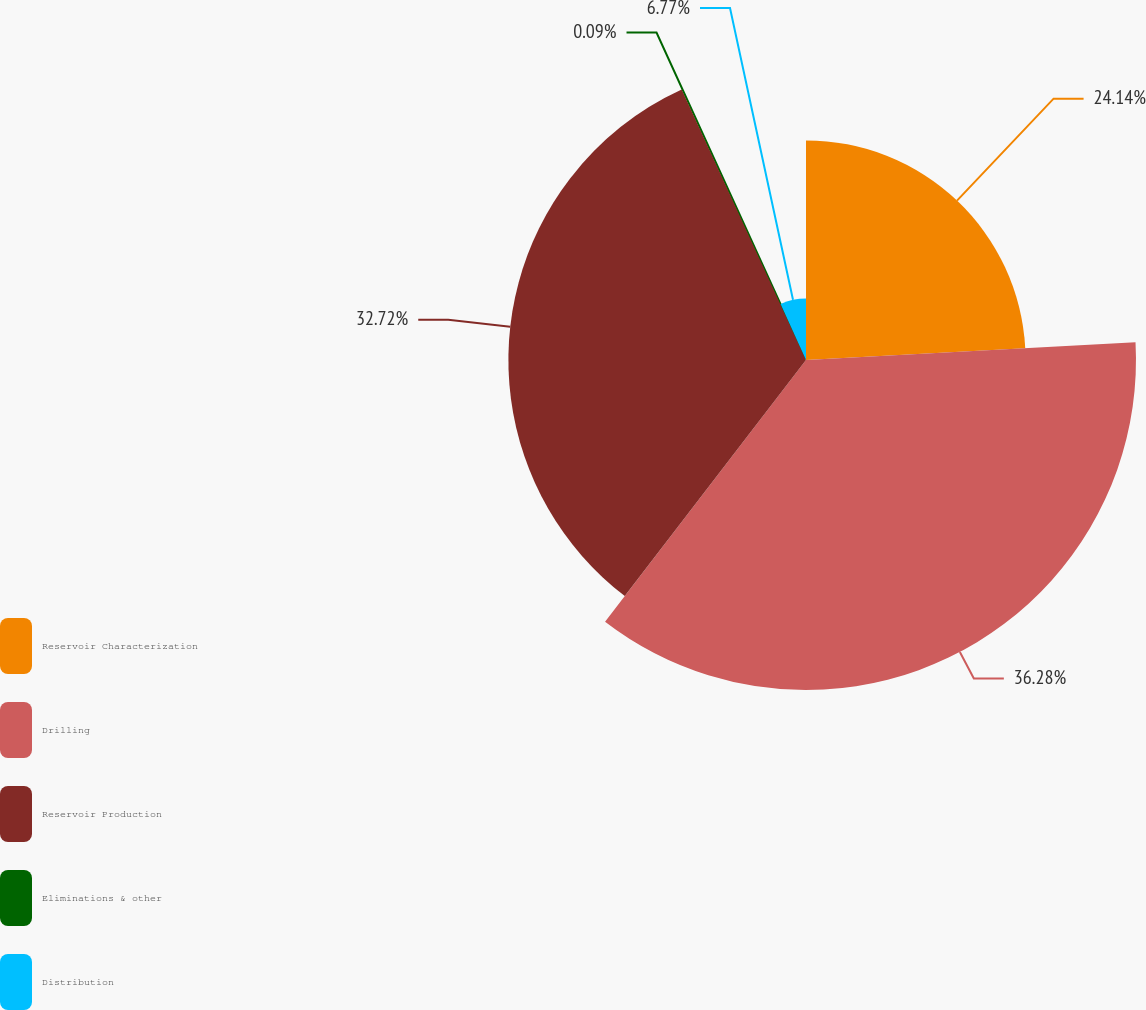Convert chart to OTSL. <chart><loc_0><loc_0><loc_500><loc_500><pie_chart><fcel>Reservoir Characterization<fcel>Drilling<fcel>Reservoir Production<fcel>Eliminations & other<fcel>Distribution<nl><fcel>24.14%<fcel>36.28%<fcel>32.72%<fcel>0.09%<fcel>6.77%<nl></chart> 